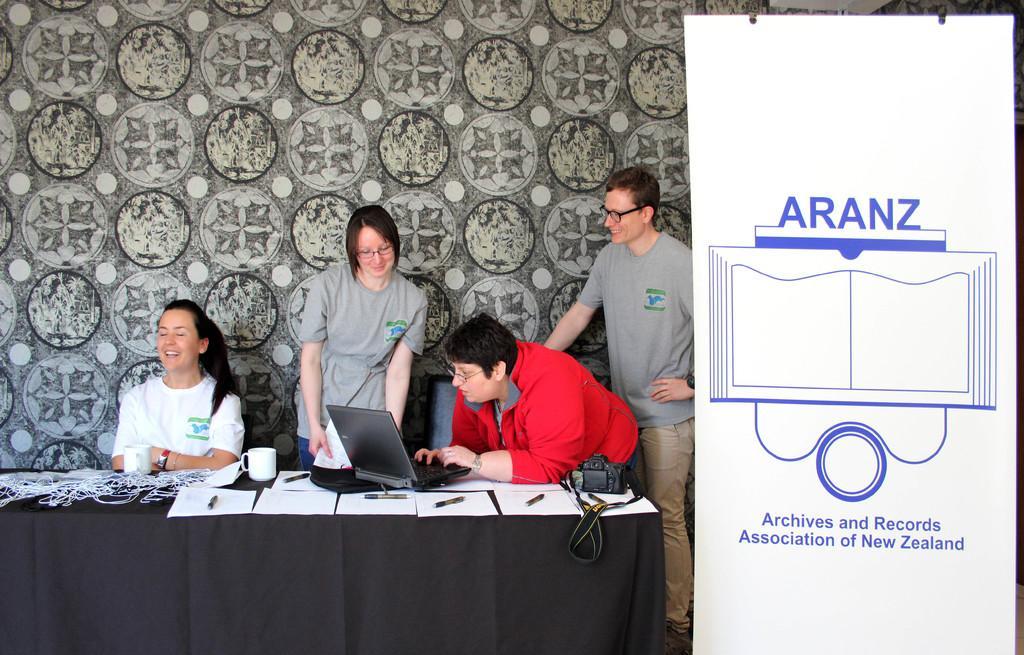Please provide a concise description of this image. Here we can see four persons. This is a table. On the table there is a cloth, papers, pens, cup, camera, and a laptop. This is a banner. In the background we can see a wall. 